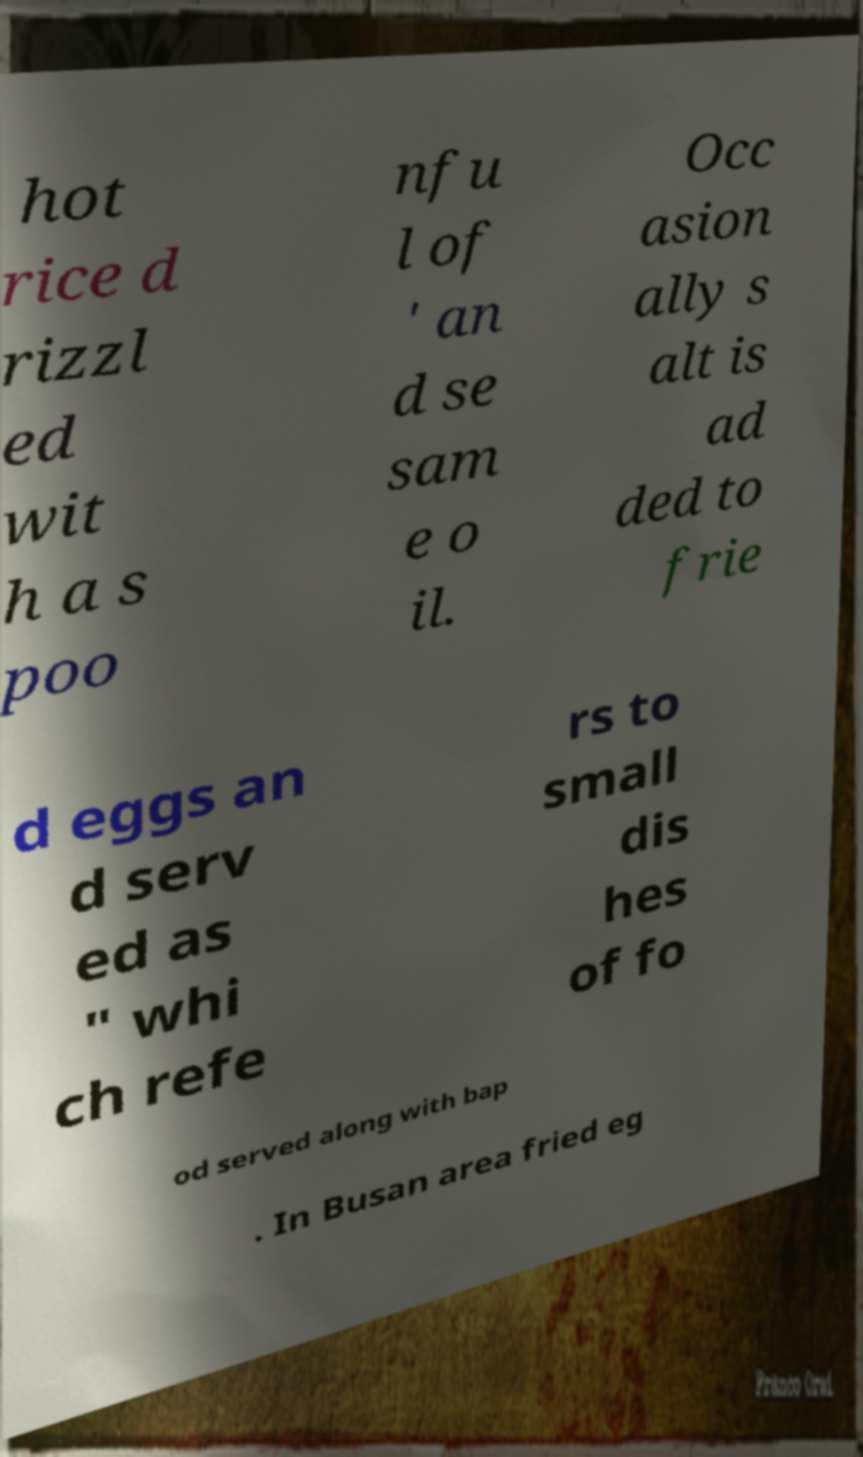Please read and relay the text visible in this image. What does it say? hot rice d rizzl ed wit h a s poo nfu l of ' an d se sam e o il. Occ asion ally s alt is ad ded to frie d eggs an d serv ed as " whi ch refe rs to small dis hes of fo od served along with bap . In Busan area fried eg 